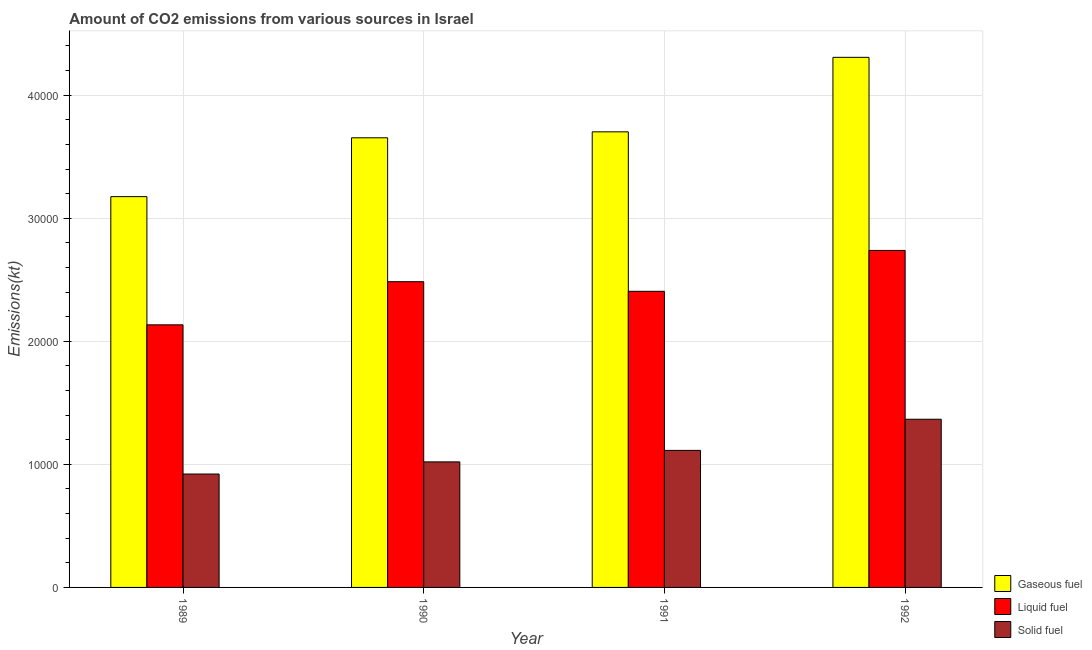Are the number of bars on each tick of the X-axis equal?
Offer a terse response. Yes. How many bars are there on the 2nd tick from the right?
Make the answer very short. 3. What is the amount of co2 emissions from gaseous fuel in 1990?
Keep it short and to the point. 3.65e+04. Across all years, what is the maximum amount of co2 emissions from gaseous fuel?
Offer a very short reply. 4.31e+04. Across all years, what is the minimum amount of co2 emissions from gaseous fuel?
Offer a very short reply. 3.18e+04. What is the total amount of co2 emissions from gaseous fuel in the graph?
Your response must be concise. 1.48e+05. What is the difference between the amount of co2 emissions from solid fuel in 1989 and that in 1990?
Ensure brevity in your answer.  -986.42. What is the difference between the amount of co2 emissions from solid fuel in 1989 and the amount of co2 emissions from gaseous fuel in 1991?
Make the answer very short. -1921.51. What is the average amount of co2 emissions from gaseous fuel per year?
Keep it short and to the point. 3.71e+04. In the year 1990, what is the difference between the amount of co2 emissions from gaseous fuel and amount of co2 emissions from solid fuel?
Offer a terse response. 0. What is the ratio of the amount of co2 emissions from gaseous fuel in 1990 to that in 1991?
Offer a terse response. 0.99. Is the amount of co2 emissions from gaseous fuel in 1989 less than that in 1991?
Offer a very short reply. Yes. Is the difference between the amount of co2 emissions from solid fuel in 1991 and 1992 greater than the difference between the amount of co2 emissions from liquid fuel in 1991 and 1992?
Keep it short and to the point. No. What is the difference between the highest and the second highest amount of co2 emissions from gaseous fuel?
Your answer should be very brief. 6054.22. What is the difference between the highest and the lowest amount of co2 emissions from liquid fuel?
Give a very brief answer. 6046.88. In how many years, is the amount of co2 emissions from gaseous fuel greater than the average amount of co2 emissions from gaseous fuel taken over all years?
Your answer should be very brief. 1. Is the sum of the amount of co2 emissions from solid fuel in 1990 and 1992 greater than the maximum amount of co2 emissions from gaseous fuel across all years?
Offer a very short reply. Yes. What does the 3rd bar from the left in 1992 represents?
Your answer should be very brief. Solid fuel. What does the 3rd bar from the right in 1990 represents?
Your answer should be very brief. Gaseous fuel. Is it the case that in every year, the sum of the amount of co2 emissions from gaseous fuel and amount of co2 emissions from liquid fuel is greater than the amount of co2 emissions from solid fuel?
Offer a very short reply. Yes. Are all the bars in the graph horizontal?
Keep it short and to the point. No. Are the values on the major ticks of Y-axis written in scientific E-notation?
Provide a succinct answer. No. How many legend labels are there?
Your answer should be very brief. 3. What is the title of the graph?
Your response must be concise. Amount of CO2 emissions from various sources in Israel. What is the label or title of the X-axis?
Give a very brief answer. Year. What is the label or title of the Y-axis?
Keep it short and to the point. Emissions(kt). What is the Emissions(kt) in Gaseous fuel in 1989?
Make the answer very short. 3.18e+04. What is the Emissions(kt) in Liquid fuel in 1989?
Offer a terse response. 2.13e+04. What is the Emissions(kt) in Solid fuel in 1989?
Your answer should be compact. 9215.17. What is the Emissions(kt) in Gaseous fuel in 1990?
Your response must be concise. 3.65e+04. What is the Emissions(kt) of Liquid fuel in 1990?
Ensure brevity in your answer.  2.48e+04. What is the Emissions(kt) in Solid fuel in 1990?
Give a very brief answer. 1.02e+04. What is the Emissions(kt) in Gaseous fuel in 1991?
Your answer should be very brief. 3.70e+04. What is the Emissions(kt) in Liquid fuel in 1991?
Offer a terse response. 2.41e+04. What is the Emissions(kt) in Solid fuel in 1991?
Offer a very short reply. 1.11e+04. What is the Emissions(kt) in Gaseous fuel in 1992?
Your answer should be compact. 4.31e+04. What is the Emissions(kt) of Liquid fuel in 1992?
Your response must be concise. 2.74e+04. What is the Emissions(kt) in Solid fuel in 1992?
Your answer should be compact. 1.37e+04. Across all years, what is the maximum Emissions(kt) in Gaseous fuel?
Offer a very short reply. 4.31e+04. Across all years, what is the maximum Emissions(kt) in Liquid fuel?
Give a very brief answer. 2.74e+04. Across all years, what is the maximum Emissions(kt) in Solid fuel?
Your response must be concise. 1.37e+04. Across all years, what is the minimum Emissions(kt) of Gaseous fuel?
Ensure brevity in your answer.  3.18e+04. Across all years, what is the minimum Emissions(kt) in Liquid fuel?
Your answer should be very brief. 2.13e+04. Across all years, what is the minimum Emissions(kt) of Solid fuel?
Your response must be concise. 9215.17. What is the total Emissions(kt) of Gaseous fuel in the graph?
Your answer should be compact. 1.48e+05. What is the total Emissions(kt) in Liquid fuel in the graph?
Offer a terse response. 9.76e+04. What is the total Emissions(kt) of Solid fuel in the graph?
Provide a short and direct response. 4.42e+04. What is the difference between the Emissions(kt) in Gaseous fuel in 1989 and that in 1990?
Ensure brevity in your answer.  -4781.77. What is the difference between the Emissions(kt) of Liquid fuel in 1989 and that in 1990?
Provide a short and direct response. -3505.65. What is the difference between the Emissions(kt) in Solid fuel in 1989 and that in 1990?
Your response must be concise. -986.42. What is the difference between the Emissions(kt) of Gaseous fuel in 1989 and that in 1991?
Keep it short and to the point. -5265.81. What is the difference between the Emissions(kt) in Liquid fuel in 1989 and that in 1991?
Your answer should be compact. -2724.58. What is the difference between the Emissions(kt) in Solid fuel in 1989 and that in 1991?
Give a very brief answer. -1921.51. What is the difference between the Emissions(kt) of Gaseous fuel in 1989 and that in 1992?
Provide a succinct answer. -1.13e+04. What is the difference between the Emissions(kt) in Liquid fuel in 1989 and that in 1992?
Offer a terse response. -6046.88. What is the difference between the Emissions(kt) of Solid fuel in 1989 and that in 1992?
Ensure brevity in your answer.  -4451.74. What is the difference between the Emissions(kt) in Gaseous fuel in 1990 and that in 1991?
Provide a short and direct response. -484.04. What is the difference between the Emissions(kt) of Liquid fuel in 1990 and that in 1991?
Provide a succinct answer. 781.07. What is the difference between the Emissions(kt) of Solid fuel in 1990 and that in 1991?
Offer a very short reply. -935.09. What is the difference between the Emissions(kt) in Gaseous fuel in 1990 and that in 1992?
Ensure brevity in your answer.  -6538.26. What is the difference between the Emissions(kt) of Liquid fuel in 1990 and that in 1992?
Your answer should be very brief. -2541.23. What is the difference between the Emissions(kt) of Solid fuel in 1990 and that in 1992?
Ensure brevity in your answer.  -3465.32. What is the difference between the Emissions(kt) of Gaseous fuel in 1991 and that in 1992?
Your answer should be compact. -6054.22. What is the difference between the Emissions(kt) of Liquid fuel in 1991 and that in 1992?
Your response must be concise. -3322.3. What is the difference between the Emissions(kt) of Solid fuel in 1991 and that in 1992?
Ensure brevity in your answer.  -2530.23. What is the difference between the Emissions(kt) in Gaseous fuel in 1989 and the Emissions(kt) in Liquid fuel in 1990?
Provide a short and direct response. 6912.3. What is the difference between the Emissions(kt) in Gaseous fuel in 1989 and the Emissions(kt) in Solid fuel in 1990?
Provide a succinct answer. 2.16e+04. What is the difference between the Emissions(kt) in Liquid fuel in 1989 and the Emissions(kt) in Solid fuel in 1990?
Your answer should be very brief. 1.11e+04. What is the difference between the Emissions(kt) of Gaseous fuel in 1989 and the Emissions(kt) of Liquid fuel in 1991?
Make the answer very short. 7693.37. What is the difference between the Emissions(kt) in Gaseous fuel in 1989 and the Emissions(kt) in Solid fuel in 1991?
Keep it short and to the point. 2.06e+04. What is the difference between the Emissions(kt) in Liquid fuel in 1989 and the Emissions(kt) in Solid fuel in 1991?
Provide a succinct answer. 1.02e+04. What is the difference between the Emissions(kt) in Gaseous fuel in 1989 and the Emissions(kt) in Liquid fuel in 1992?
Provide a short and direct response. 4371.06. What is the difference between the Emissions(kt) in Gaseous fuel in 1989 and the Emissions(kt) in Solid fuel in 1992?
Offer a very short reply. 1.81e+04. What is the difference between the Emissions(kt) in Liquid fuel in 1989 and the Emissions(kt) in Solid fuel in 1992?
Keep it short and to the point. 7671.36. What is the difference between the Emissions(kt) in Gaseous fuel in 1990 and the Emissions(kt) in Liquid fuel in 1991?
Your response must be concise. 1.25e+04. What is the difference between the Emissions(kt) of Gaseous fuel in 1990 and the Emissions(kt) of Solid fuel in 1991?
Make the answer very short. 2.54e+04. What is the difference between the Emissions(kt) of Liquid fuel in 1990 and the Emissions(kt) of Solid fuel in 1991?
Your answer should be compact. 1.37e+04. What is the difference between the Emissions(kt) of Gaseous fuel in 1990 and the Emissions(kt) of Liquid fuel in 1992?
Your answer should be very brief. 9152.83. What is the difference between the Emissions(kt) of Gaseous fuel in 1990 and the Emissions(kt) of Solid fuel in 1992?
Offer a very short reply. 2.29e+04. What is the difference between the Emissions(kt) of Liquid fuel in 1990 and the Emissions(kt) of Solid fuel in 1992?
Your answer should be compact. 1.12e+04. What is the difference between the Emissions(kt) in Gaseous fuel in 1991 and the Emissions(kt) in Liquid fuel in 1992?
Give a very brief answer. 9636.88. What is the difference between the Emissions(kt) of Gaseous fuel in 1991 and the Emissions(kt) of Solid fuel in 1992?
Give a very brief answer. 2.34e+04. What is the difference between the Emissions(kt) in Liquid fuel in 1991 and the Emissions(kt) in Solid fuel in 1992?
Give a very brief answer. 1.04e+04. What is the average Emissions(kt) in Gaseous fuel per year?
Keep it short and to the point. 3.71e+04. What is the average Emissions(kt) in Liquid fuel per year?
Provide a short and direct response. 2.44e+04. What is the average Emissions(kt) of Solid fuel per year?
Your response must be concise. 1.11e+04. In the year 1989, what is the difference between the Emissions(kt) of Gaseous fuel and Emissions(kt) of Liquid fuel?
Give a very brief answer. 1.04e+04. In the year 1989, what is the difference between the Emissions(kt) in Gaseous fuel and Emissions(kt) in Solid fuel?
Offer a terse response. 2.25e+04. In the year 1989, what is the difference between the Emissions(kt) of Liquid fuel and Emissions(kt) of Solid fuel?
Give a very brief answer. 1.21e+04. In the year 1990, what is the difference between the Emissions(kt) in Gaseous fuel and Emissions(kt) in Liquid fuel?
Offer a very short reply. 1.17e+04. In the year 1990, what is the difference between the Emissions(kt) in Gaseous fuel and Emissions(kt) in Solid fuel?
Offer a very short reply. 2.63e+04. In the year 1990, what is the difference between the Emissions(kt) of Liquid fuel and Emissions(kt) of Solid fuel?
Provide a short and direct response. 1.46e+04. In the year 1991, what is the difference between the Emissions(kt) of Gaseous fuel and Emissions(kt) of Liquid fuel?
Make the answer very short. 1.30e+04. In the year 1991, what is the difference between the Emissions(kt) of Gaseous fuel and Emissions(kt) of Solid fuel?
Your answer should be very brief. 2.59e+04. In the year 1991, what is the difference between the Emissions(kt) of Liquid fuel and Emissions(kt) of Solid fuel?
Keep it short and to the point. 1.29e+04. In the year 1992, what is the difference between the Emissions(kt) in Gaseous fuel and Emissions(kt) in Liquid fuel?
Make the answer very short. 1.57e+04. In the year 1992, what is the difference between the Emissions(kt) of Gaseous fuel and Emissions(kt) of Solid fuel?
Your answer should be very brief. 2.94e+04. In the year 1992, what is the difference between the Emissions(kt) of Liquid fuel and Emissions(kt) of Solid fuel?
Your answer should be very brief. 1.37e+04. What is the ratio of the Emissions(kt) of Gaseous fuel in 1989 to that in 1990?
Your answer should be compact. 0.87. What is the ratio of the Emissions(kt) in Liquid fuel in 1989 to that in 1990?
Give a very brief answer. 0.86. What is the ratio of the Emissions(kt) in Solid fuel in 1989 to that in 1990?
Offer a terse response. 0.9. What is the ratio of the Emissions(kt) of Gaseous fuel in 1989 to that in 1991?
Your response must be concise. 0.86. What is the ratio of the Emissions(kt) of Liquid fuel in 1989 to that in 1991?
Give a very brief answer. 0.89. What is the ratio of the Emissions(kt) in Solid fuel in 1989 to that in 1991?
Offer a very short reply. 0.83. What is the ratio of the Emissions(kt) in Gaseous fuel in 1989 to that in 1992?
Your response must be concise. 0.74. What is the ratio of the Emissions(kt) in Liquid fuel in 1989 to that in 1992?
Give a very brief answer. 0.78. What is the ratio of the Emissions(kt) of Solid fuel in 1989 to that in 1992?
Keep it short and to the point. 0.67. What is the ratio of the Emissions(kt) of Gaseous fuel in 1990 to that in 1991?
Give a very brief answer. 0.99. What is the ratio of the Emissions(kt) of Liquid fuel in 1990 to that in 1991?
Your answer should be very brief. 1.03. What is the ratio of the Emissions(kt) of Solid fuel in 1990 to that in 1991?
Provide a short and direct response. 0.92. What is the ratio of the Emissions(kt) of Gaseous fuel in 1990 to that in 1992?
Your response must be concise. 0.85. What is the ratio of the Emissions(kt) in Liquid fuel in 1990 to that in 1992?
Provide a short and direct response. 0.91. What is the ratio of the Emissions(kt) in Solid fuel in 1990 to that in 1992?
Give a very brief answer. 0.75. What is the ratio of the Emissions(kt) in Gaseous fuel in 1991 to that in 1992?
Your response must be concise. 0.86. What is the ratio of the Emissions(kt) in Liquid fuel in 1991 to that in 1992?
Your response must be concise. 0.88. What is the ratio of the Emissions(kt) in Solid fuel in 1991 to that in 1992?
Your response must be concise. 0.81. What is the difference between the highest and the second highest Emissions(kt) of Gaseous fuel?
Make the answer very short. 6054.22. What is the difference between the highest and the second highest Emissions(kt) in Liquid fuel?
Keep it short and to the point. 2541.23. What is the difference between the highest and the second highest Emissions(kt) of Solid fuel?
Your answer should be very brief. 2530.23. What is the difference between the highest and the lowest Emissions(kt) of Gaseous fuel?
Your response must be concise. 1.13e+04. What is the difference between the highest and the lowest Emissions(kt) of Liquid fuel?
Provide a short and direct response. 6046.88. What is the difference between the highest and the lowest Emissions(kt) of Solid fuel?
Keep it short and to the point. 4451.74. 